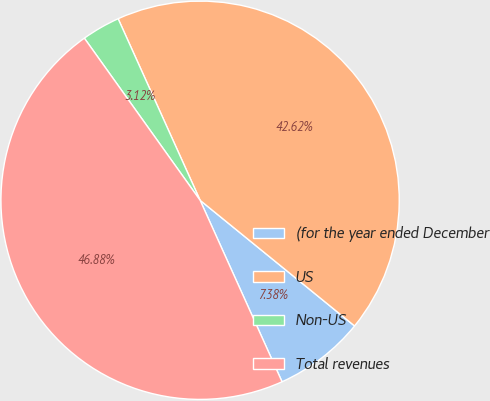<chart> <loc_0><loc_0><loc_500><loc_500><pie_chart><fcel>(for the year ended December<fcel>US<fcel>Non-US<fcel>Total revenues<nl><fcel>7.38%<fcel>42.62%<fcel>3.12%<fcel>46.88%<nl></chart> 